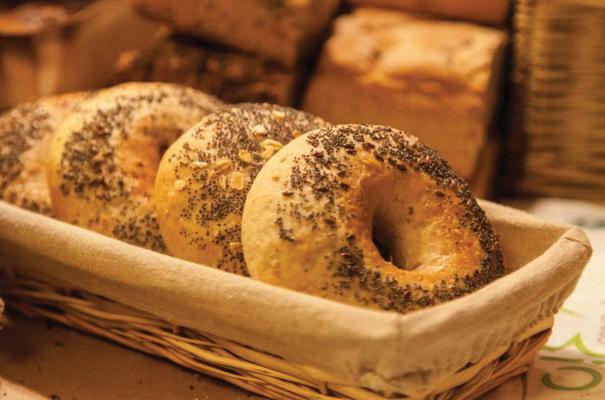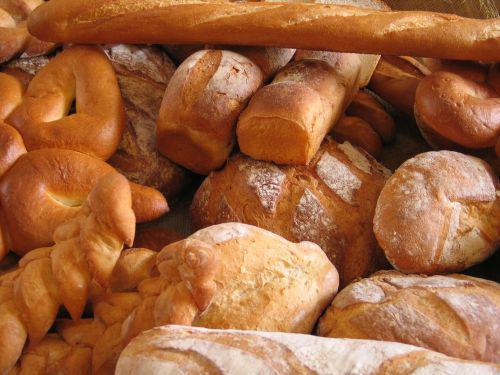The first image is the image on the left, the second image is the image on the right. Considering the images on both sides, is "The left image includes multiple roundish baked loaves with a single slice-mark across the top, and they are not in a container." valid? Answer yes or no. No. The first image is the image on the left, the second image is the image on the right. Considering the images on both sides, is "There are at least 4 pieces of bread held in a light colored wicker basket." valid? Answer yes or no. Yes. 